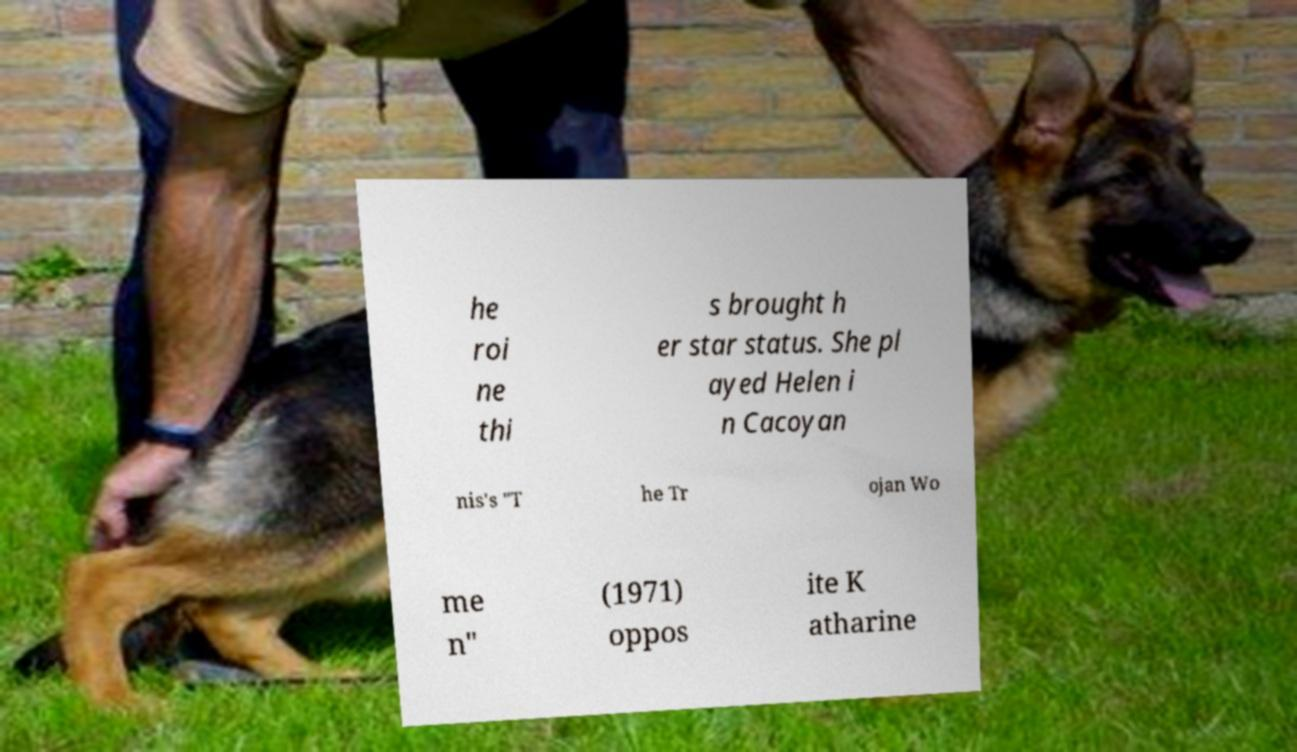Can you accurately transcribe the text from the provided image for me? he roi ne thi s brought h er star status. She pl ayed Helen i n Cacoyan nis's "T he Tr ojan Wo me n" (1971) oppos ite K atharine 